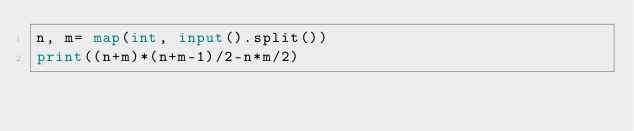<code> <loc_0><loc_0><loc_500><loc_500><_Python_>n, m= map(int, input().split())
print((n+m)*(n+m-1)/2-n*m/2)</code> 